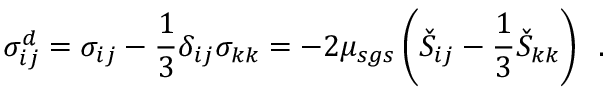<formula> <loc_0><loc_0><loc_500><loc_500>\sigma _ { i j } ^ { d } = \sigma _ { i j } - \frac { 1 } { 3 } \delta _ { i j } \sigma _ { k k } = - 2 \mu _ { s g s } \left ( \check { S } _ { i j } - \frac { 1 } { 3 } \check { S } _ { k k } \right ) \, .</formula> 